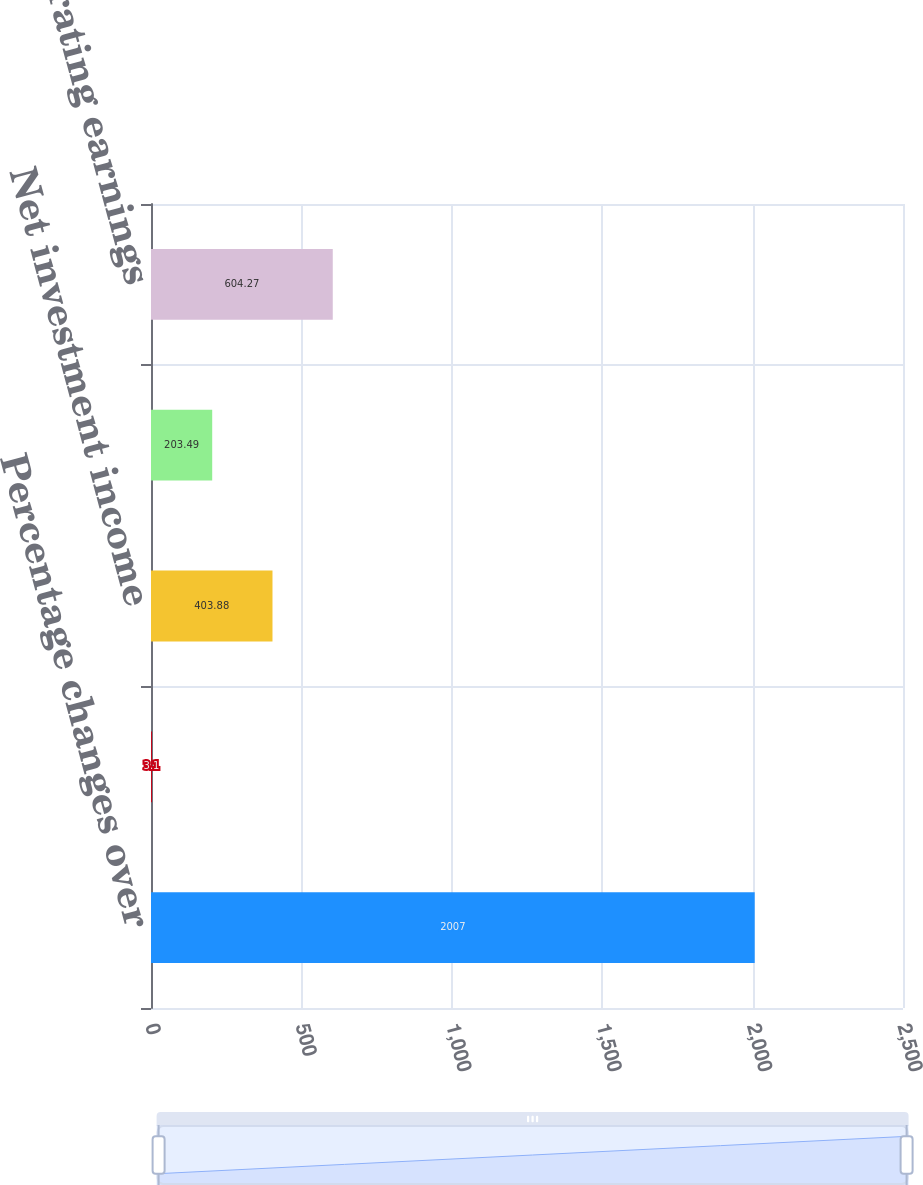<chart> <loc_0><loc_0><loc_500><loc_500><bar_chart><fcel>Percentage changes over<fcel>Premium income<fcel>Net investment income<fcel>Total operating revenues<fcel>Pretax operating earnings<nl><fcel>2007<fcel>3.1<fcel>403.88<fcel>203.49<fcel>604.27<nl></chart> 